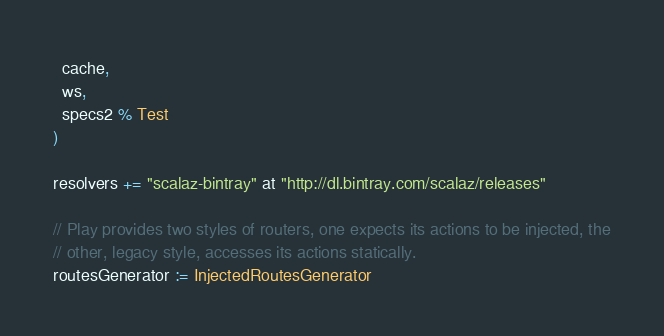Convert code to text. <code><loc_0><loc_0><loc_500><loc_500><_Scala_>  cache,
  ws,
  specs2 % Test
)

resolvers += "scalaz-bintray" at "http://dl.bintray.com/scalaz/releases"

// Play provides two styles of routers, one expects its actions to be injected, the
// other, legacy style, accesses its actions statically.
routesGenerator := InjectedRoutesGenerator
</code> 